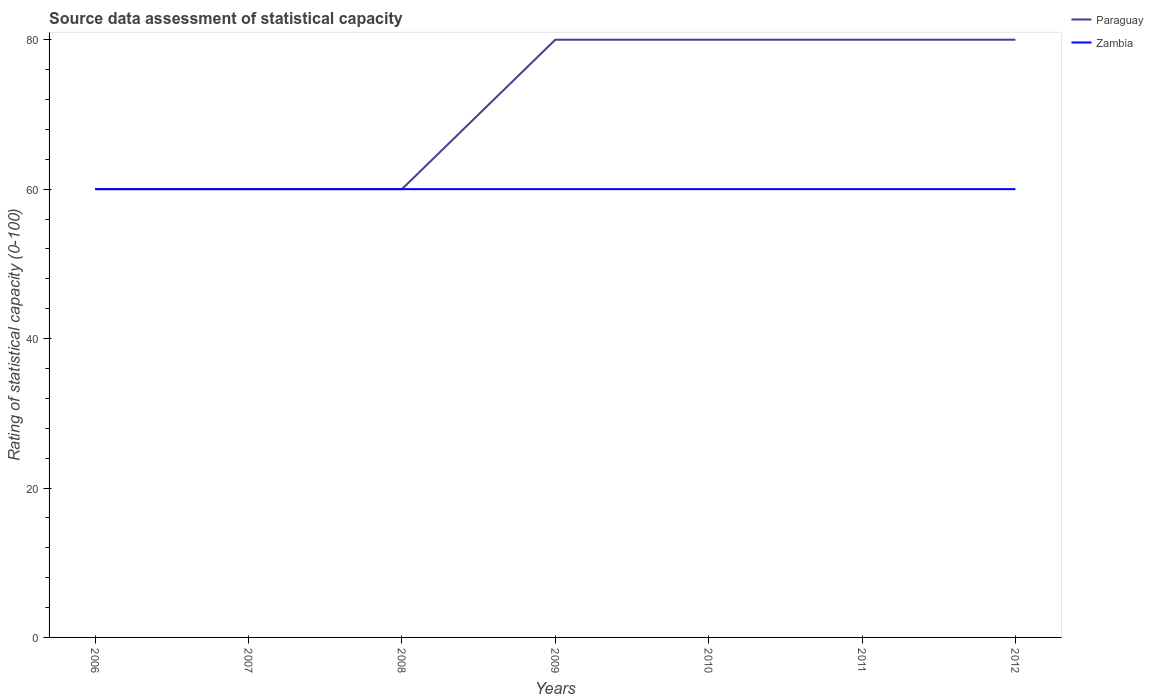Does the line corresponding to Paraguay intersect with the line corresponding to Zambia?
Your answer should be compact. Yes. Across all years, what is the maximum rating of statistical capacity in Paraguay?
Provide a short and direct response. 60. What is the total rating of statistical capacity in Paraguay in the graph?
Make the answer very short. -20. What is the difference between the highest and the lowest rating of statistical capacity in Zambia?
Your response must be concise. 0. Is the rating of statistical capacity in Zambia strictly greater than the rating of statistical capacity in Paraguay over the years?
Your answer should be very brief. No. How many lines are there?
Your answer should be very brief. 2. Are the values on the major ticks of Y-axis written in scientific E-notation?
Your answer should be compact. No. Does the graph contain any zero values?
Offer a terse response. No. Does the graph contain grids?
Provide a short and direct response. No. Where does the legend appear in the graph?
Your answer should be compact. Top right. What is the title of the graph?
Offer a very short reply. Source data assessment of statistical capacity. Does "Grenada" appear as one of the legend labels in the graph?
Keep it short and to the point. No. What is the label or title of the X-axis?
Provide a succinct answer. Years. What is the label or title of the Y-axis?
Keep it short and to the point. Rating of statistical capacity (0-100). What is the Rating of statistical capacity (0-100) in Paraguay in 2006?
Provide a succinct answer. 60. What is the Rating of statistical capacity (0-100) in Zambia in 2006?
Provide a succinct answer. 60. What is the Rating of statistical capacity (0-100) of Zambia in 2010?
Provide a short and direct response. 60. What is the Rating of statistical capacity (0-100) in Paraguay in 2011?
Ensure brevity in your answer.  80. What is the Rating of statistical capacity (0-100) in Zambia in 2011?
Your answer should be very brief. 60. What is the total Rating of statistical capacity (0-100) in Zambia in the graph?
Give a very brief answer. 420. What is the difference between the Rating of statistical capacity (0-100) in Paraguay in 2006 and that in 2007?
Make the answer very short. 0. What is the difference between the Rating of statistical capacity (0-100) of Zambia in 2006 and that in 2007?
Keep it short and to the point. 0. What is the difference between the Rating of statistical capacity (0-100) in Paraguay in 2006 and that in 2008?
Provide a short and direct response. 0. What is the difference between the Rating of statistical capacity (0-100) of Paraguay in 2006 and that in 2011?
Ensure brevity in your answer.  -20. What is the difference between the Rating of statistical capacity (0-100) in Paraguay in 2006 and that in 2012?
Provide a succinct answer. -20. What is the difference between the Rating of statistical capacity (0-100) in Zambia in 2006 and that in 2012?
Offer a very short reply. 0. What is the difference between the Rating of statistical capacity (0-100) in Paraguay in 2007 and that in 2008?
Your answer should be very brief. 0. What is the difference between the Rating of statistical capacity (0-100) in Paraguay in 2007 and that in 2009?
Provide a succinct answer. -20. What is the difference between the Rating of statistical capacity (0-100) of Zambia in 2007 and that in 2009?
Your response must be concise. 0. What is the difference between the Rating of statistical capacity (0-100) in Zambia in 2007 and that in 2010?
Provide a short and direct response. 0. What is the difference between the Rating of statistical capacity (0-100) of Paraguay in 2007 and that in 2011?
Your response must be concise. -20. What is the difference between the Rating of statistical capacity (0-100) of Zambia in 2007 and that in 2011?
Make the answer very short. 0. What is the difference between the Rating of statistical capacity (0-100) in Paraguay in 2008 and that in 2009?
Give a very brief answer. -20. What is the difference between the Rating of statistical capacity (0-100) of Paraguay in 2008 and that in 2010?
Provide a short and direct response. -20. What is the difference between the Rating of statistical capacity (0-100) of Paraguay in 2008 and that in 2011?
Offer a terse response. -20. What is the difference between the Rating of statistical capacity (0-100) of Zambia in 2008 and that in 2011?
Your answer should be compact. 0. What is the difference between the Rating of statistical capacity (0-100) of Paraguay in 2009 and that in 2010?
Your answer should be compact. 0. What is the difference between the Rating of statistical capacity (0-100) in Paraguay in 2009 and that in 2011?
Keep it short and to the point. 0. What is the difference between the Rating of statistical capacity (0-100) of Paraguay in 2010 and that in 2011?
Offer a very short reply. 0. What is the difference between the Rating of statistical capacity (0-100) of Paraguay in 2010 and that in 2012?
Make the answer very short. 0. What is the difference between the Rating of statistical capacity (0-100) in Paraguay in 2011 and that in 2012?
Offer a terse response. 0. What is the difference between the Rating of statistical capacity (0-100) of Zambia in 2011 and that in 2012?
Provide a succinct answer. 0. What is the difference between the Rating of statistical capacity (0-100) of Paraguay in 2006 and the Rating of statistical capacity (0-100) of Zambia in 2008?
Make the answer very short. 0. What is the difference between the Rating of statistical capacity (0-100) in Paraguay in 2006 and the Rating of statistical capacity (0-100) in Zambia in 2010?
Provide a short and direct response. 0. What is the difference between the Rating of statistical capacity (0-100) of Paraguay in 2006 and the Rating of statistical capacity (0-100) of Zambia in 2011?
Give a very brief answer. 0. What is the difference between the Rating of statistical capacity (0-100) of Paraguay in 2007 and the Rating of statistical capacity (0-100) of Zambia in 2008?
Offer a terse response. 0. What is the difference between the Rating of statistical capacity (0-100) in Paraguay in 2007 and the Rating of statistical capacity (0-100) in Zambia in 2011?
Your response must be concise. 0. What is the difference between the Rating of statistical capacity (0-100) in Paraguay in 2007 and the Rating of statistical capacity (0-100) in Zambia in 2012?
Offer a very short reply. 0. What is the difference between the Rating of statistical capacity (0-100) in Paraguay in 2008 and the Rating of statistical capacity (0-100) in Zambia in 2009?
Offer a terse response. 0. What is the difference between the Rating of statistical capacity (0-100) of Paraguay in 2008 and the Rating of statistical capacity (0-100) of Zambia in 2011?
Your answer should be compact. 0. What is the difference between the Rating of statistical capacity (0-100) in Paraguay in 2008 and the Rating of statistical capacity (0-100) in Zambia in 2012?
Make the answer very short. 0. What is the difference between the Rating of statistical capacity (0-100) of Paraguay in 2009 and the Rating of statistical capacity (0-100) of Zambia in 2012?
Give a very brief answer. 20. What is the difference between the Rating of statistical capacity (0-100) of Paraguay in 2010 and the Rating of statistical capacity (0-100) of Zambia in 2012?
Provide a succinct answer. 20. What is the difference between the Rating of statistical capacity (0-100) of Paraguay in 2011 and the Rating of statistical capacity (0-100) of Zambia in 2012?
Your response must be concise. 20. What is the average Rating of statistical capacity (0-100) in Paraguay per year?
Your answer should be compact. 71.43. What is the average Rating of statistical capacity (0-100) of Zambia per year?
Your answer should be compact. 60. In the year 2006, what is the difference between the Rating of statistical capacity (0-100) of Paraguay and Rating of statistical capacity (0-100) of Zambia?
Ensure brevity in your answer.  0. In the year 2009, what is the difference between the Rating of statistical capacity (0-100) of Paraguay and Rating of statistical capacity (0-100) of Zambia?
Provide a succinct answer. 20. In the year 2010, what is the difference between the Rating of statistical capacity (0-100) in Paraguay and Rating of statistical capacity (0-100) in Zambia?
Provide a succinct answer. 20. In the year 2012, what is the difference between the Rating of statistical capacity (0-100) of Paraguay and Rating of statistical capacity (0-100) of Zambia?
Your response must be concise. 20. What is the ratio of the Rating of statistical capacity (0-100) of Paraguay in 2006 to that in 2007?
Keep it short and to the point. 1. What is the ratio of the Rating of statistical capacity (0-100) in Zambia in 2006 to that in 2007?
Ensure brevity in your answer.  1. What is the ratio of the Rating of statistical capacity (0-100) in Paraguay in 2006 to that in 2009?
Keep it short and to the point. 0.75. What is the ratio of the Rating of statistical capacity (0-100) in Zambia in 2006 to that in 2010?
Offer a very short reply. 1. What is the ratio of the Rating of statistical capacity (0-100) in Paraguay in 2007 to that in 2009?
Give a very brief answer. 0.75. What is the ratio of the Rating of statistical capacity (0-100) of Zambia in 2007 to that in 2009?
Your response must be concise. 1. What is the ratio of the Rating of statistical capacity (0-100) of Zambia in 2007 to that in 2011?
Ensure brevity in your answer.  1. What is the ratio of the Rating of statistical capacity (0-100) in Zambia in 2007 to that in 2012?
Keep it short and to the point. 1. What is the ratio of the Rating of statistical capacity (0-100) of Zambia in 2008 to that in 2009?
Provide a short and direct response. 1. What is the ratio of the Rating of statistical capacity (0-100) of Zambia in 2008 to that in 2012?
Ensure brevity in your answer.  1. What is the ratio of the Rating of statistical capacity (0-100) of Paraguay in 2009 to that in 2010?
Offer a terse response. 1. What is the ratio of the Rating of statistical capacity (0-100) in Zambia in 2009 to that in 2010?
Your answer should be compact. 1. What is the ratio of the Rating of statistical capacity (0-100) in Paraguay in 2010 to that in 2012?
Keep it short and to the point. 1. What is the ratio of the Rating of statistical capacity (0-100) of Zambia in 2010 to that in 2012?
Ensure brevity in your answer.  1. What is the ratio of the Rating of statistical capacity (0-100) of Paraguay in 2011 to that in 2012?
Provide a succinct answer. 1. What is the difference between the highest and the second highest Rating of statistical capacity (0-100) in Paraguay?
Make the answer very short. 0. What is the difference between the highest and the second highest Rating of statistical capacity (0-100) in Zambia?
Keep it short and to the point. 0. What is the difference between the highest and the lowest Rating of statistical capacity (0-100) in Zambia?
Ensure brevity in your answer.  0. 